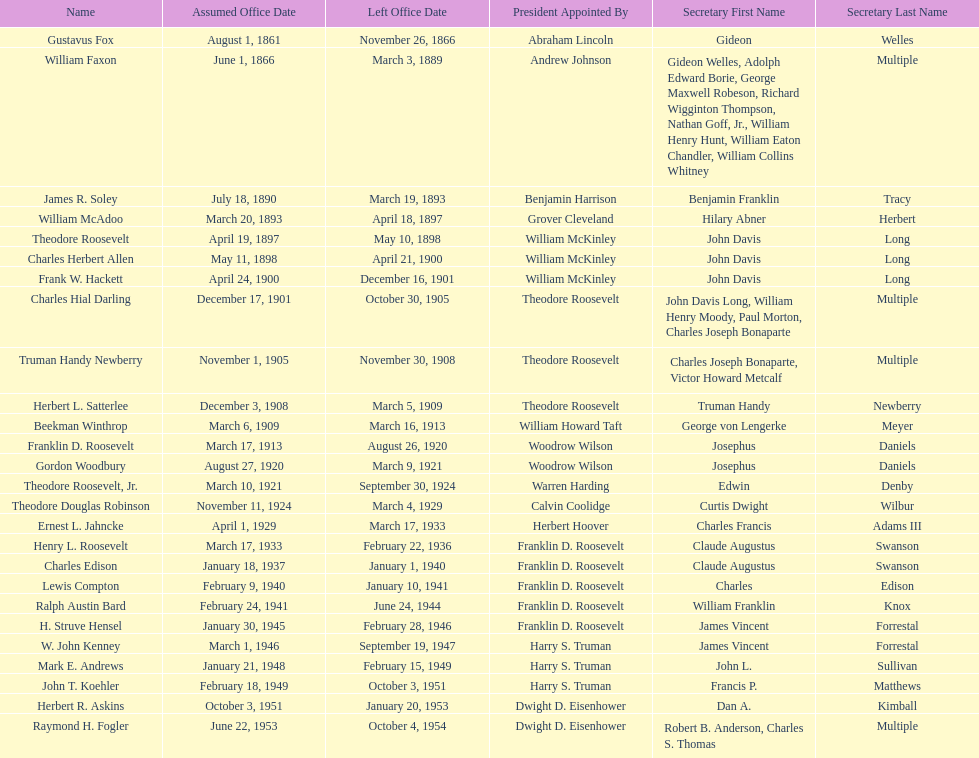When did raymond h. fogler leave the office of assistant secretary of the navy? October 4, 1954. 